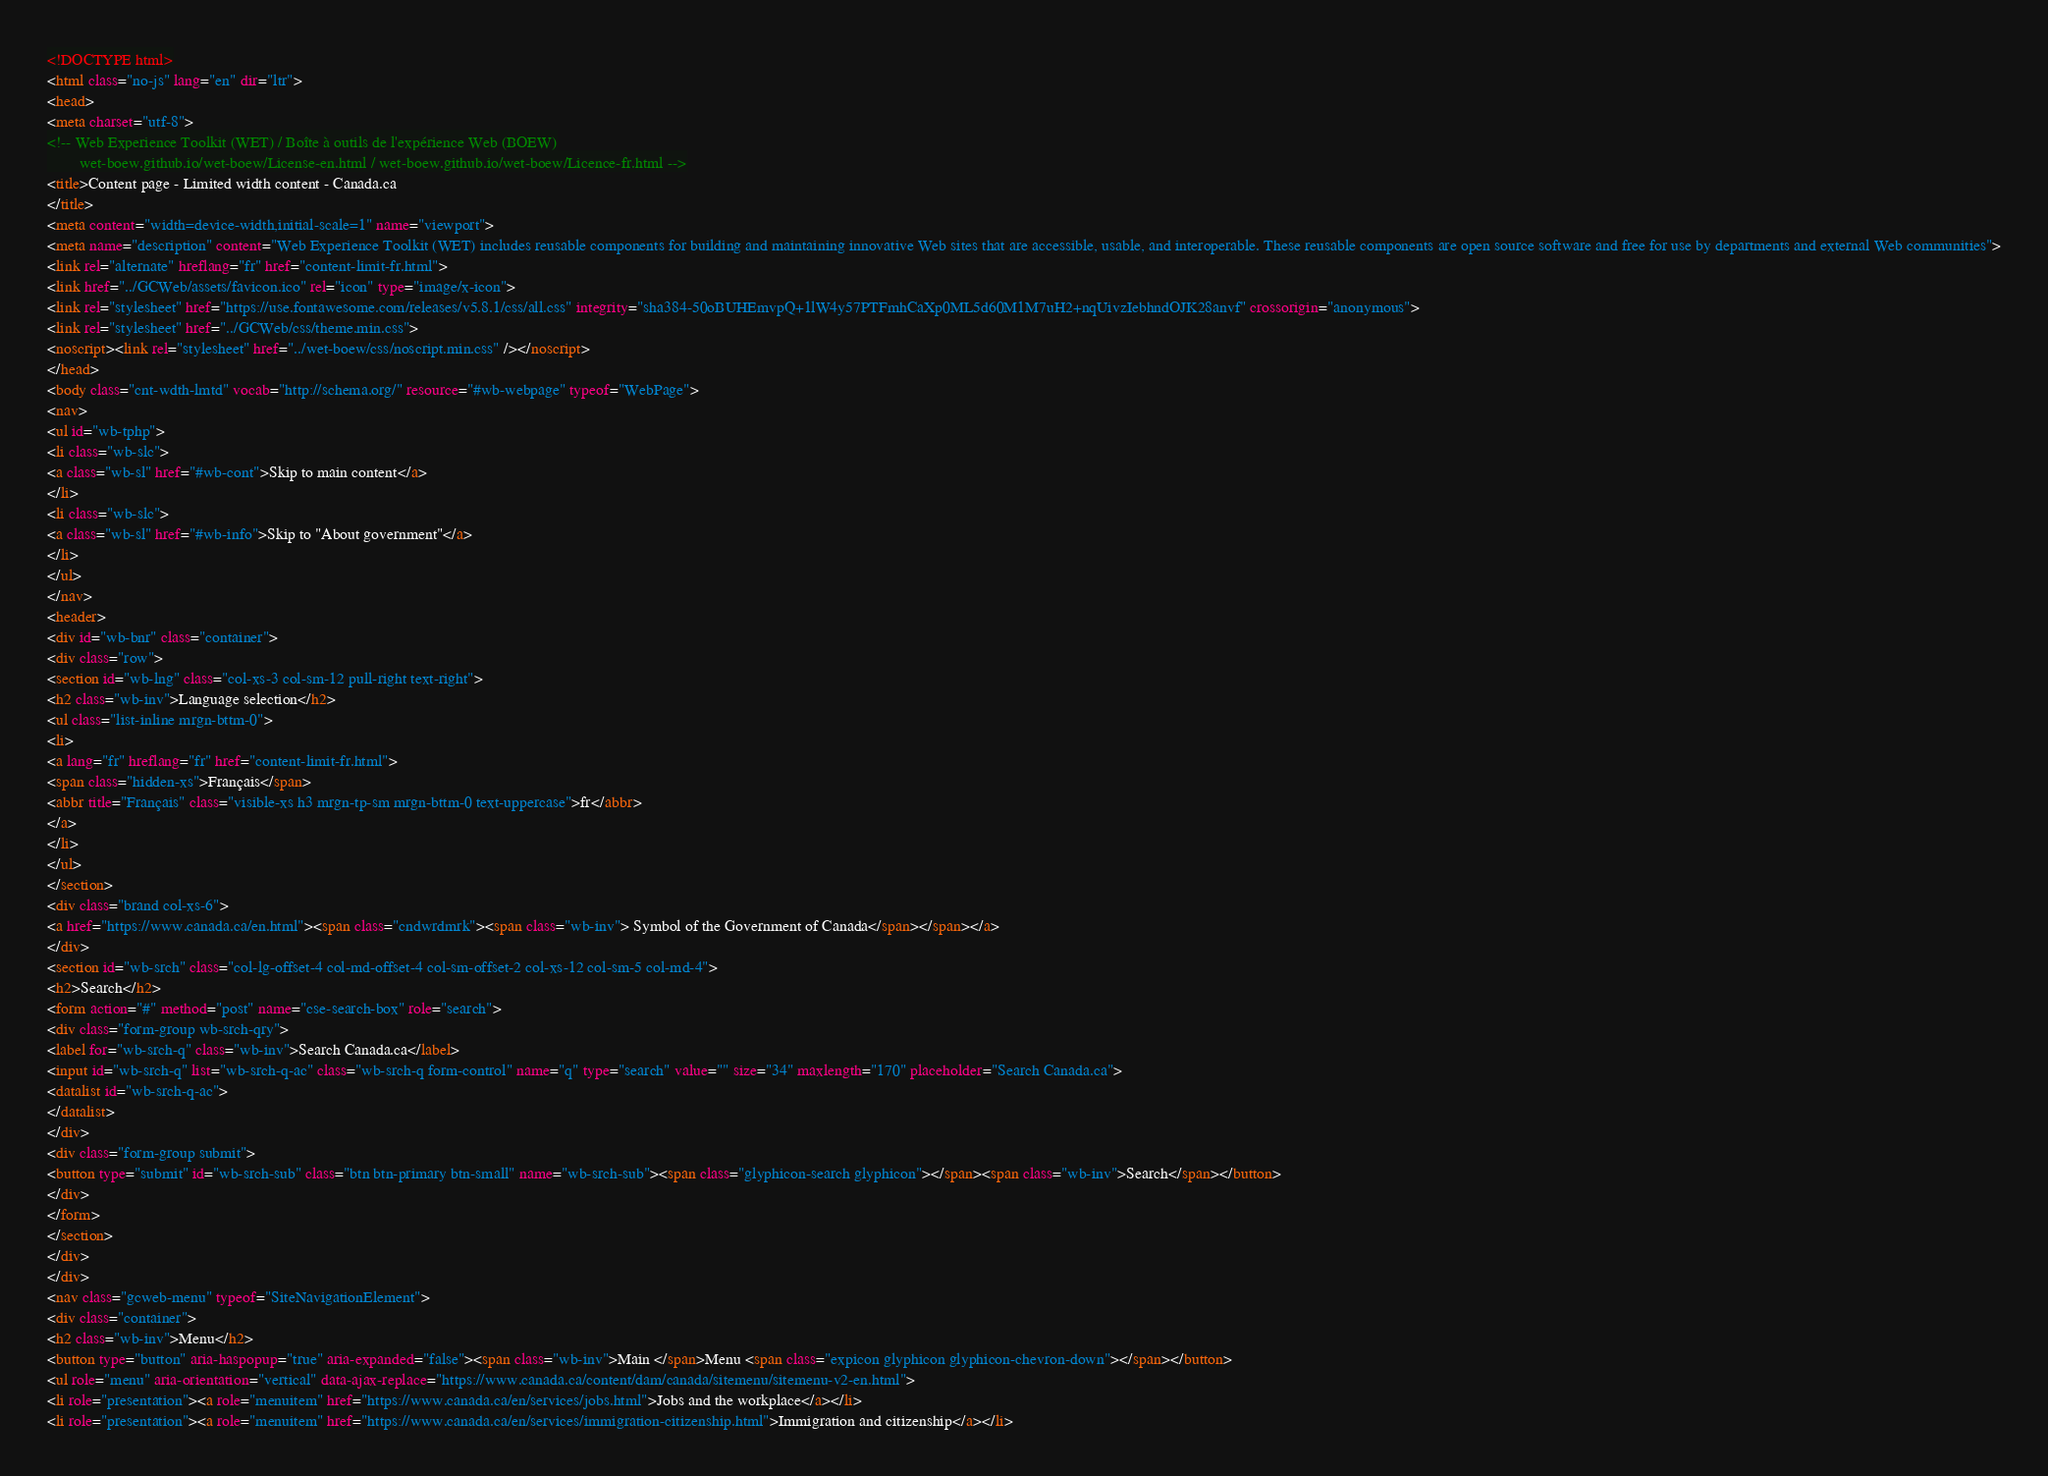<code> <loc_0><loc_0><loc_500><loc_500><_HTML_><!DOCTYPE html>
<html class="no-js" lang="en" dir="ltr">
<head>
<meta charset="utf-8">
<!-- Web Experience Toolkit (WET) / Boîte à outils de l'expérience Web (BOEW)
		wet-boew.github.io/wet-boew/License-en.html / wet-boew.github.io/wet-boew/Licence-fr.html -->
<title>Content page - Limited width content - Canada.ca
</title>
<meta content="width=device-width,initial-scale=1" name="viewport">
<meta name="description" content="Web Experience Toolkit (WET) includes reusable components for building and maintaining innovative Web sites that are accessible, usable, and interoperable. These reusable components are open source software and free for use by departments and external Web communities">
<link rel="alternate" hreflang="fr" href="content-limit-fr.html">
<link href="../GCWeb/assets/favicon.ico" rel="icon" type="image/x-icon">
<link rel="stylesheet" href="https://use.fontawesome.com/releases/v5.8.1/css/all.css" integrity="sha384-50oBUHEmvpQ+1lW4y57PTFmhCaXp0ML5d60M1M7uH2+nqUivzIebhndOJK28anvf" crossorigin="anonymous">
<link rel="stylesheet" href="../GCWeb/css/theme.min.css">
<noscript><link rel="stylesheet" href="../wet-boew/css/noscript.min.css" /></noscript>
</head>
<body class="cnt-wdth-lmtd" vocab="http://schema.org/" resource="#wb-webpage" typeof="WebPage">
<nav>
<ul id="wb-tphp">
<li class="wb-slc">
<a class="wb-sl" href="#wb-cont">Skip to main content</a>
</li>
<li class="wb-slc">
<a class="wb-sl" href="#wb-info">Skip to "About government"</a>
</li>
</ul>
</nav>
<header>
<div id="wb-bnr" class="container">
<div class="row">
<section id="wb-lng" class="col-xs-3 col-sm-12 pull-right text-right">
<h2 class="wb-inv">Language selection</h2>
<ul class="list-inline mrgn-bttm-0">
<li>
<a lang="fr" hreflang="fr" href="content-limit-fr.html">
<span class="hidden-xs">Français</span>
<abbr title="Français" class="visible-xs h3 mrgn-tp-sm mrgn-bttm-0 text-uppercase">fr</abbr>
</a>
</li>
</ul>
</section>
<div class="brand col-xs-6">
<a href="https://www.canada.ca/en.html"><span class="cndwrdmrk"><span class="wb-inv"> Symbol of the Government of Canada</span></span></a>
</div>
<section id="wb-srch" class="col-lg-offset-4 col-md-offset-4 col-sm-offset-2 col-xs-12 col-sm-5 col-md-4">
<h2>Search</h2>
<form action="#" method="post" name="cse-search-box" role="search">
<div class="form-group wb-srch-qry">
<label for="wb-srch-q" class="wb-inv">Search Canada.ca</label>
<input id="wb-srch-q" list="wb-srch-q-ac" class="wb-srch-q form-control" name="q" type="search" value="" size="34" maxlength="170" placeholder="Search Canada.ca">
<datalist id="wb-srch-q-ac">
</datalist>
</div>
<div class="form-group submit">
<button type="submit" id="wb-srch-sub" class="btn btn-primary btn-small" name="wb-srch-sub"><span class="glyphicon-search glyphicon"></span><span class="wb-inv">Search</span></button>
</div>
</form>
</section>
</div>
</div>
<nav class="gcweb-menu" typeof="SiteNavigationElement">
<div class="container">
<h2 class="wb-inv">Menu</h2>
<button type="button" aria-haspopup="true" aria-expanded="false"><span class="wb-inv">Main </span>Menu <span class="expicon glyphicon glyphicon-chevron-down"></span></button>
<ul role="menu" aria-orientation="vertical" data-ajax-replace="https://www.canada.ca/content/dam/canada/sitemenu/sitemenu-v2-en.html">
<li role="presentation"><a role="menuitem" href="https://www.canada.ca/en/services/jobs.html">Jobs and the workplace</a></li>
<li role="presentation"><a role="menuitem" href="https://www.canada.ca/en/services/immigration-citizenship.html">Immigration and citizenship</a></li></code> 